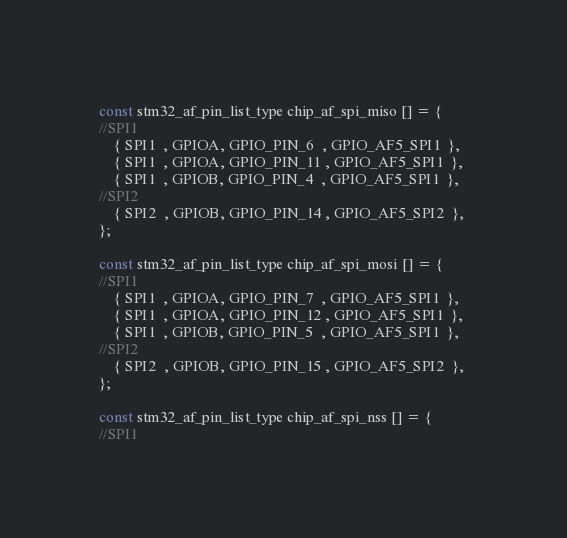Convert code to text. <code><loc_0><loc_0><loc_500><loc_500><_C_>
const stm32_af_pin_list_type chip_af_spi_miso [] = {
//SPI1
    { SPI1  , GPIOA, GPIO_PIN_6  , GPIO_AF5_SPI1  }, 
    { SPI1  , GPIOA, GPIO_PIN_11 , GPIO_AF5_SPI1  }, 
    { SPI1  , GPIOB, GPIO_PIN_4  , GPIO_AF5_SPI1  }, 
//SPI2
    { SPI2  , GPIOB, GPIO_PIN_14 , GPIO_AF5_SPI2  }, 
}; 

const stm32_af_pin_list_type chip_af_spi_mosi [] = {
//SPI1
    { SPI1  , GPIOA, GPIO_PIN_7  , GPIO_AF5_SPI1  }, 
    { SPI1  , GPIOA, GPIO_PIN_12 , GPIO_AF5_SPI1  }, 
    { SPI1  , GPIOB, GPIO_PIN_5  , GPIO_AF5_SPI1  }, 
//SPI2
    { SPI2  , GPIOB, GPIO_PIN_15 , GPIO_AF5_SPI2  }, 
}; 

const stm32_af_pin_list_type chip_af_spi_nss [] = {
//SPI1</code> 